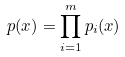Convert formula to latex. <formula><loc_0><loc_0><loc_500><loc_500>p ( x ) = \prod _ { i = 1 } ^ { m } p _ { i } ( x )</formula> 